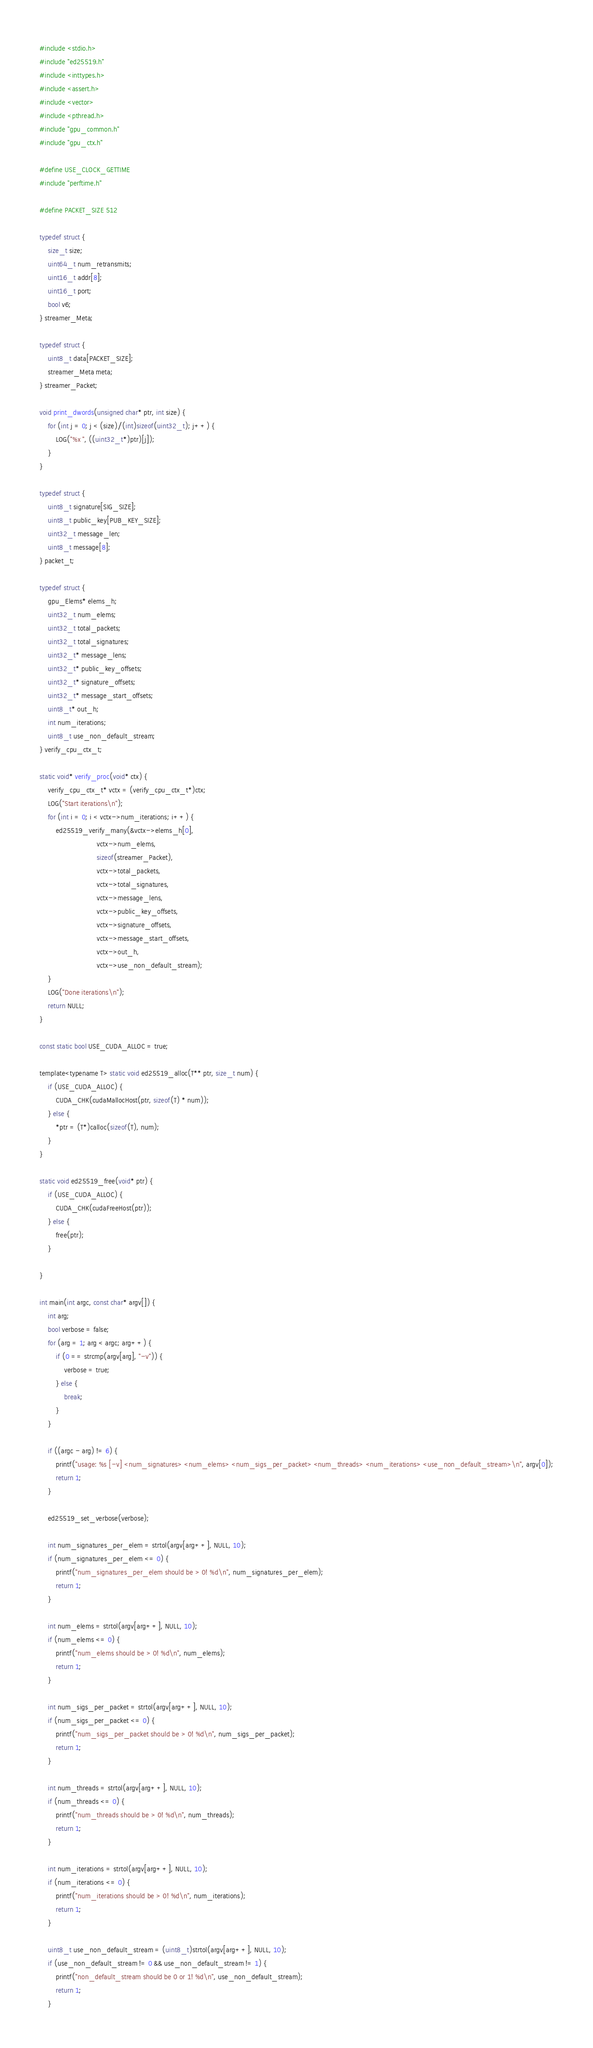<code> <loc_0><loc_0><loc_500><loc_500><_Cuda_>#include <stdio.h>
#include "ed25519.h"
#include <inttypes.h>
#include <assert.h>
#include <vector>
#include <pthread.h>
#include "gpu_common.h"
#include "gpu_ctx.h"

#define USE_CLOCK_GETTIME
#include "perftime.h"

#define PACKET_SIZE 512

typedef struct {
    size_t size;
    uint64_t num_retransmits;
    uint16_t addr[8];
    uint16_t port;
    bool v6;
} streamer_Meta;

typedef struct {
    uint8_t data[PACKET_SIZE];
    streamer_Meta meta;
} streamer_Packet;

void print_dwords(unsigned char* ptr, int size) {
    for (int j = 0; j < (size)/(int)sizeof(uint32_t); j++) {
        LOG("%x ", ((uint32_t*)ptr)[j]);
    }
}

typedef struct {
    uint8_t signature[SIG_SIZE];
    uint8_t public_key[PUB_KEY_SIZE];
    uint32_t message_len;
    uint8_t message[8];
} packet_t;

typedef struct {
    gpu_Elems* elems_h;
    uint32_t num_elems;
    uint32_t total_packets;
    uint32_t total_signatures;
    uint32_t* message_lens;
    uint32_t* public_key_offsets;
    uint32_t* signature_offsets;
    uint32_t* message_start_offsets;
    uint8_t* out_h;
    int num_iterations;
    uint8_t use_non_default_stream;
} verify_cpu_ctx_t;

static void* verify_proc(void* ctx) {
    verify_cpu_ctx_t* vctx = (verify_cpu_ctx_t*)ctx;
    LOG("Start iterations\n");
    for (int i = 0; i < vctx->num_iterations; i++) {
        ed25519_verify_many(&vctx->elems_h[0],
                            vctx->num_elems,
                            sizeof(streamer_Packet),
                            vctx->total_packets,
                            vctx->total_signatures,
                            vctx->message_lens,
                            vctx->public_key_offsets,
                            vctx->signature_offsets,
                            vctx->message_start_offsets,
                            vctx->out_h,
                            vctx->use_non_default_stream);
    }
    LOG("Done iterations\n");
    return NULL;
}

const static bool USE_CUDA_ALLOC = true;

template<typename T> static void ed25519_alloc(T** ptr, size_t num) {
    if (USE_CUDA_ALLOC) {
        CUDA_CHK(cudaMallocHost(ptr, sizeof(T) * num));
    } else {
        *ptr = (T*)calloc(sizeof(T), num);
    }
}

static void ed25519_free(void* ptr) {
    if (USE_CUDA_ALLOC) {
        CUDA_CHK(cudaFreeHost(ptr));
    } else {
        free(ptr);
    }

}

int main(int argc, const char* argv[]) {
    int arg;
    bool verbose = false;
    for (arg = 1; arg < argc; arg++) {
        if (0 == strcmp(argv[arg], "-v")) {
            verbose = true;
        } else {
            break;
        }
    }

    if ((argc - arg) != 6) {
        printf("usage: %s [-v] <num_signatures> <num_elems> <num_sigs_per_packet> <num_threads> <num_iterations> <use_non_default_stream>\n", argv[0]);
        return 1;
    }

    ed25519_set_verbose(verbose);

    int num_signatures_per_elem = strtol(argv[arg++], NULL, 10);
    if (num_signatures_per_elem <= 0) {
        printf("num_signatures_per_elem should be > 0! %d\n", num_signatures_per_elem);
        return 1;
    }

    int num_elems = strtol(argv[arg++], NULL, 10);
    if (num_elems <= 0) {
        printf("num_elems should be > 0! %d\n", num_elems);
        return 1;
    }

    int num_sigs_per_packet = strtol(argv[arg++], NULL, 10);
    if (num_sigs_per_packet <= 0) {
        printf("num_sigs_per_packet should be > 0! %d\n", num_sigs_per_packet);
        return 1;
    }

    int num_threads = strtol(argv[arg++], NULL, 10);
    if (num_threads <= 0) {
        printf("num_threads should be > 0! %d\n", num_threads);
        return 1;
    }

    int num_iterations = strtol(argv[arg++], NULL, 10);
    if (num_iterations <= 0) {
        printf("num_iterations should be > 0! %d\n", num_iterations);
        return 1;
    }

    uint8_t use_non_default_stream = (uint8_t)strtol(argv[arg++], NULL, 10);
    if (use_non_default_stream != 0 && use_non_default_stream != 1) {
        printf("non_default_stream should be 0 or 1! %d\n", use_non_default_stream);
        return 1;
    }
</code> 